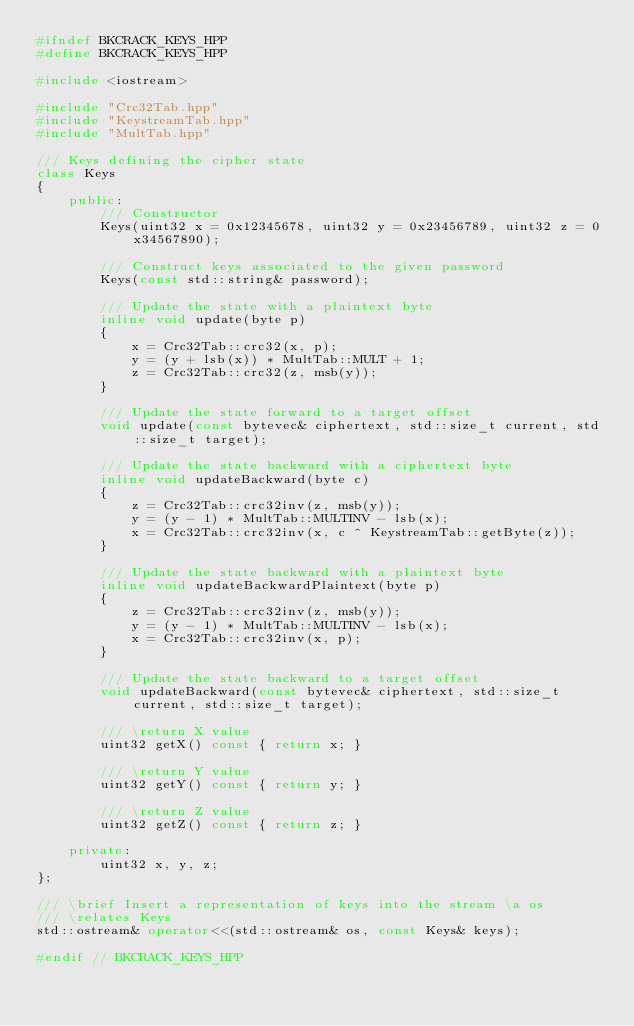Convert code to text. <code><loc_0><loc_0><loc_500><loc_500><_C++_>#ifndef BKCRACK_KEYS_HPP
#define BKCRACK_KEYS_HPP

#include <iostream>

#include "Crc32Tab.hpp"
#include "KeystreamTab.hpp"
#include "MultTab.hpp"

/// Keys defining the cipher state
class Keys
{
    public:
        /// Constructor
        Keys(uint32 x = 0x12345678, uint32 y = 0x23456789, uint32 z = 0x34567890);

        /// Construct keys associated to the given password
        Keys(const std::string& password);

        /// Update the state with a plaintext byte
        inline void update(byte p)
        {
            x = Crc32Tab::crc32(x, p);
            y = (y + lsb(x)) * MultTab::MULT + 1;
            z = Crc32Tab::crc32(z, msb(y));
        }

        /// Update the state forward to a target offset
        void update(const bytevec& ciphertext, std::size_t current, std::size_t target);

        /// Update the state backward with a ciphertext byte
        inline void updateBackward(byte c)
        {
            z = Crc32Tab::crc32inv(z, msb(y));
            y = (y - 1) * MultTab::MULTINV - lsb(x);
            x = Crc32Tab::crc32inv(x, c ^ KeystreamTab::getByte(z));
        }

        /// Update the state backward with a plaintext byte
        inline void updateBackwardPlaintext(byte p)
        {
            z = Crc32Tab::crc32inv(z, msb(y));
            y = (y - 1) * MultTab::MULTINV - lsb(x);
            x = Crc32Tab::crc32inv(x, p);
        }

        /// Update the state backward to a target offset
        void updateBackward(const bytevec& ciphertext, std::size_t current, std::size_t target);

        /// \return X value
        uint32 getX() const { return x; }

        /// \return Y value
        uint32 getY() const { return y; }

        /// \return Z value
        uint32 getZ() const { return z; }

    private:
        uint32 x, y, z;
};

/// \brief Insert a representation of keys into the stream \a os
/// \relates Keys
std::ostream& operator<<(std::ostream& os, const Keys& keys);

#endif // BKCRACK_KEYS_HPP
</code> 